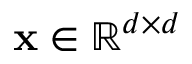Convert formula to latex. <formula><loc_0><loc_0><loc_500><loc_500>x \in \mathbb { R } ^ { d \times d }</formula> 